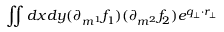Convert formula to latex. <formula><loc_0><loc_0><loc_500><loc_500>\iint d x d y ( \partial _ { m ^ { 1 } } f _ { 1 } ) ( \partial _ { m ^ { 2 } } f _ { 2 } ) e ^ { q _ { \perp } \cdot r _ { \perp } }</formula> 